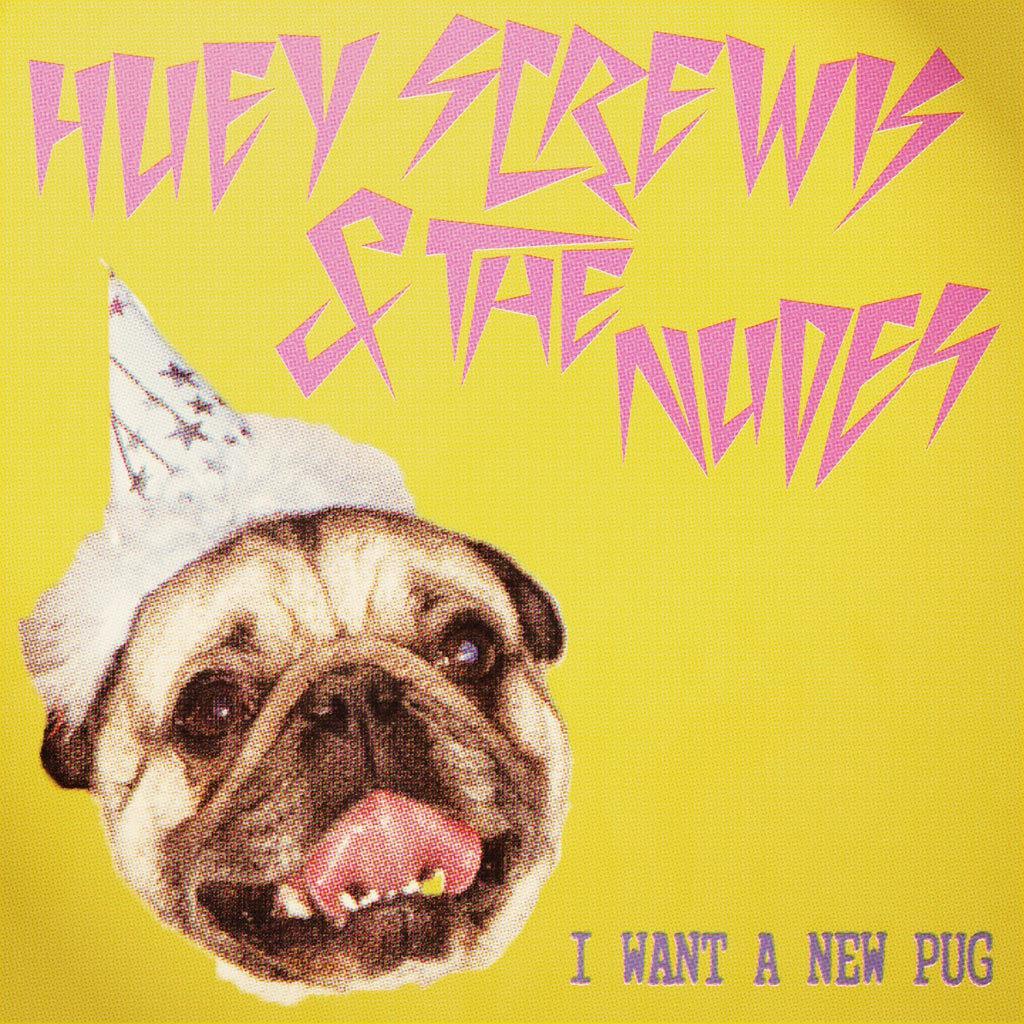How would you summarize this image in a sentence or two? In this image we can see one yellow color poster with some text and one dog face with a birthday cap. 